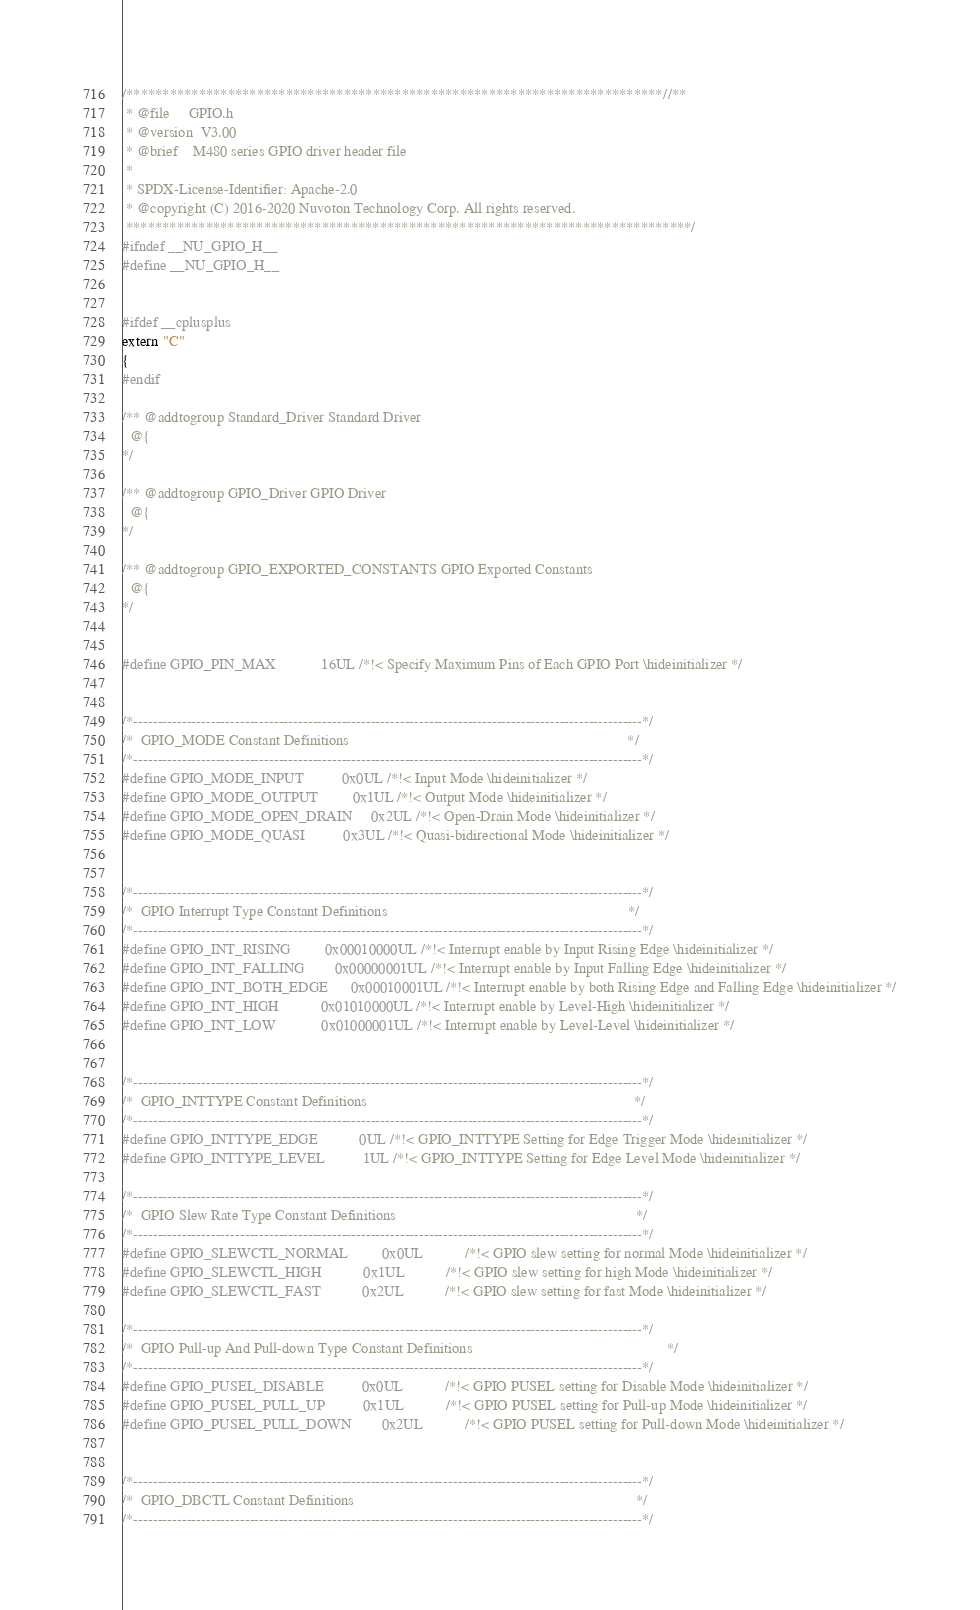<code> <loc_0><loc_0><loc_500><loc_500><_C_>/**************************************************************************//**
 * @file     GPIO.h
 * @version  V3.00
 * @brief    M480 series GPIO driver header file
 *
 * SPDX-License-Identifier: Apache-2.0
 * @copyright (C) 2016-2020 Nuvoton Technology Corp. All rights reserved.
 ******************************************************************************/
#ifndef __NU_GPIO_H__
#define __NU_GPIO_H__


#ifdef __cplusplus
extern "C"
{
#endif

/** @addtogroup Standard_Driver Standard Driver
  @{
*/

/** @addtogroup GPIO_Driver GPIO Driver
  @{
*/

/** @addtogroup GPIO_EXPORTED_CONSTANTS GPIO Exported Constants
  @{
*/


#define GPIO_PIN_MAX            16UL /*!< Specify Maximum Pins of Each GPIO Port \hideinitializer */


/*---------------------------------------------------------------------------------------------------------*/
/*  GPIO_MODE Constant Definitions                                                                         */
/*---------------------------------------------------------------------------------------------------------*/
#define GPIO_MODE_INPUT          0x0UL /*!< Input Mode \hideinitializer */
#define GPIO_MODE_OUTPUT         0x1UL /*!< Output Mode \hideinitializer */
#define GPIO_MODE_OPEN_DRAIN     0x2UL /*!< Open-Drain Mode \hideinitializer */
#define GPIO_MODE_QUASI          0x3UL /*!< Quasi-bidirectional Mode \hideinitializer */


/*---------------------------------------------------------------------------------------------------------*/
/*  GPIO Interrupt Type Constant Definitions                                                               */
/*---------------------------------------------------------------------------------------------------------*/
#define GPIO_INT_RISING         0x00010000UL /*!< Interrupt enable by Input Rising Edge \hideinitializer */
#define GPIO_INT_FALLING        0x00000001UL /*!< Interrupt enable by Input Falling Edge \hideinitializer */
#define GPIO_INT_BOTH_EDGE      0x00010001UL /*!< Interrupt enable by both Rising Edge and Falling Edge \hideinitializer */
#define GPIO_INT_HIGH           0x01010000UL /*!< Interrupt enable by Level-High \hideinitializer */
#define GPIO_INT_LOW            0x01000001UL /*!< Interrupt enable by Level-Level \hideinitializer */


/*---------------------------------------------------------------------------------------------------------*/
/*  GPIO_INTTYPE Constant Definitions                                                                      */
/*---------------------------------------------------------------------------------------------------------*/
#define GPIO_INTTYPE_EDGE           0UL /*!< GPIO_INTTYPE Setting for Edge Trigger Mode \hideinitializer */
#define GPIO_INTTYPE_LEVEL          1UL /*!< GPIO_INTTYPE Setting for Edge Level Mode \hideinitializer */

/*---------------------------------------------------------------------------------------------------------*/
/*  GPIO Slew Rate Type Constant Definitions                                                               */
/*---------------------------------------------------------------------------------------------------------*/
#define GPIO_SLEWCTL_NORMAL         0x0UL           /*!< GPIO slew setting for normal Mode \hideinitializer */
#define GPIO_SLEWCTL_HIGH           0x1UL           /*!< GPIO slew setting for high Mode \hideinitializer */
#define GPIO_SLEWCTL_FAST           0x2UL           /*!< GPIO slew setting for fast Mode \hideinitializer */

/*---------------------------------------------------------------------------------------------------------*/
/*  GPIO Pull-up And Pull-down Type Constant Definitions                                                   */
/*---------------------------------------------------------------------------------------------------------*/
#define GPIO_PUSEL_DISABLE          0x0UL           /*!< GPIO PUSEL setting for Disable Mode \hideinitializer */
#define GPIO_PUSEL_PULL_UP          0x1UL           /*!< GPIO PUSEL setting for Pull-up Mode \hideinitializer */
#define GPIO_PUSEL_PULL_DOWN        0x2UL           /*!< GPIO PUSEL setting for Pull-down Mode \hideinitializer */


/*---------------------------------------------------------------------------------------------------------*/
/*  GPIO_DBCTL Constant Definitions                                                                          */
/*---------------------------------------------------------------------------------------------------------*/</code> 